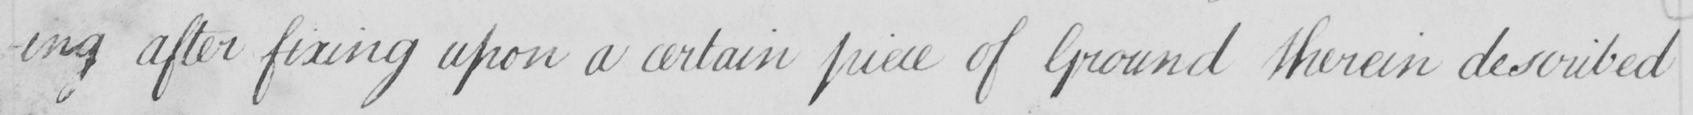Can you tell me what this handwritten text says? -ing after fixing upon a certain piece of Ground therein described 